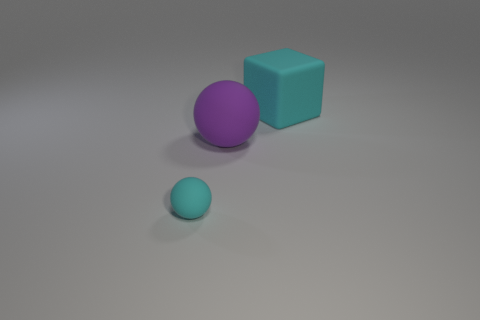Do the thing right of the large ball and the large thing on the left side of the block have the same material?
Your response must be concise. Yes. What number of small blocks are there?
Provide a succinct answer. 0. What is the shape of the large rubber thing that is behind the large purple sphere?
Your response must be concise. Cube. What number of other things are the same size as the purple object?
Provide a short and direct response. 1. There is a large rubber thing that is in front of the large cyan object; does it have the same shape as the cyan object that is in front of the cyan matte cube?
Your response must be concise. Yes. What number of matte objects are on the left side of the cyan ball?
Your answer should be very brief. 0. There is a big thing in front of the large matte block; what color is it?
Ensure brevity in your answer.  Purple. What is the color of the other matte object that is the same shape as the tiny cyan rubber thing?
Your answer should be very brief. Purple. Are there any other things that are the same color as the small matte sphere?
Ensure brevity in your answer.  Yes. Are there more purple matte things than green things?
Give a very brief answer. Yes. 